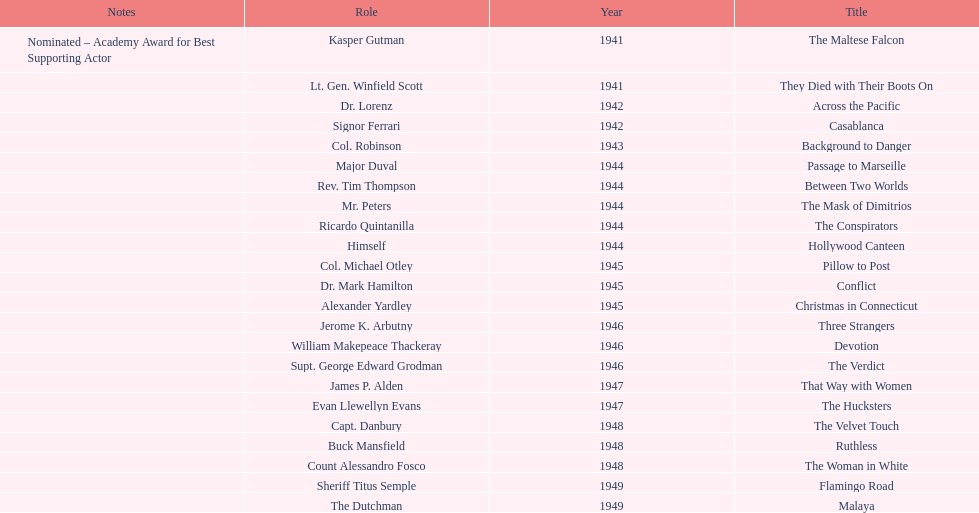How long did sydney greenstreet's acting career last? 9 years. 